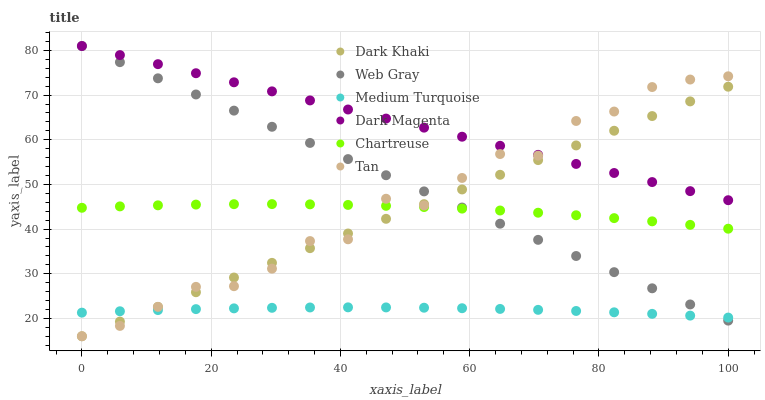Does Medium Turquoise have the minimum area under the curve?
Answer yes or no. Yes. Does Dark Magenta have the maximum area under the curve?
Answer yes or no. Yes. Does Dark Khaki have the minimum area under the curve?
Answer yes or no. No. Does Dark Khaki have the maximum area under the curve?
Answer yes or no. No. Is Web Gray the smoothest?
Answer yes or no. Yes. Is Tan the roughest?
Answer yes or no. Yes. Is Dark Magenta the smoothest?
Answer yes or no. No. Is Dark Magenta the roughest?
Answer yes or no. No. Does Dark Khaki have the lowest value?
Answer yes or no. Yes. Does Dark Magenta have the lowest value?
Answer yes or no. No. Does Dark Magenta have the highest value?
Answer yes or no. Yes. Does Dark Khaki have the highest value?
Answer yes or no. No. Is Medium Turquoise less than Dark Magenta?
Answer yes or no. Yes. Is Dark Magenta greater than Medium Turquoise?
Answer yes or no. Yes. Does Tan intersect Web Gray?
Answer yes or no. Yes. Is Tan less than Web Gray?
Answer yes or no. No. Is Tan greater than Web Gray?
Answer yes or no. No. Does Medium Turquoise intersect Dark Magenta?
Answer yes or no. No. 